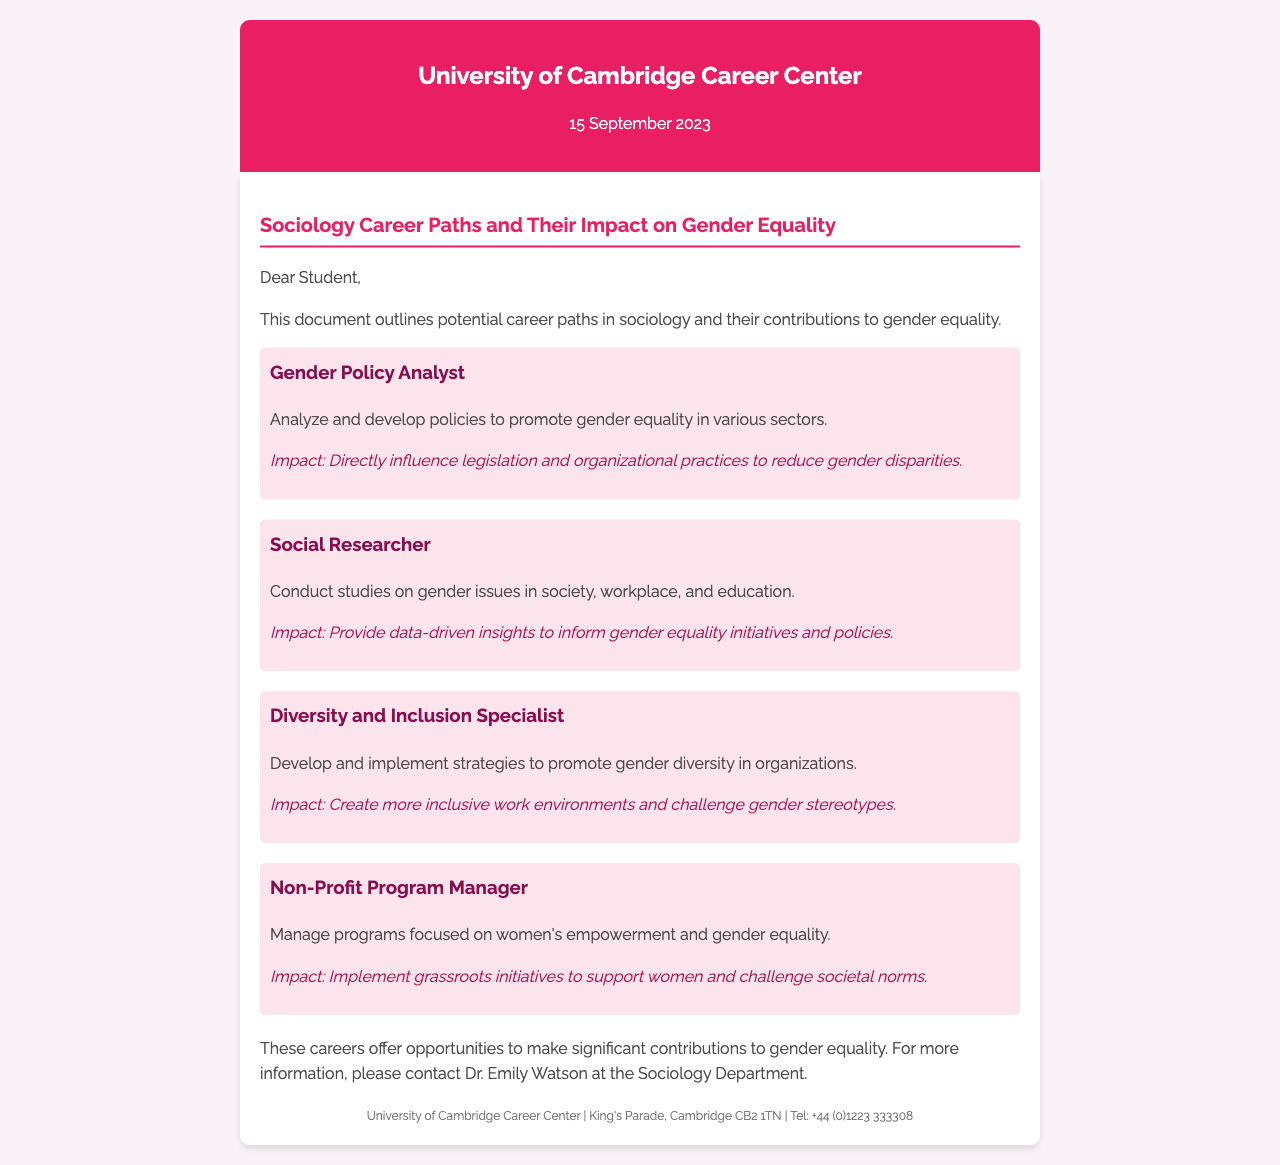What is the date of the document? The date of the document is mentioned prominently in the header.
Answer: 15 September 2023 Who sent the fax? The sender's information is included in the header of the document.
Answer: University of Cambridge Career Center What is the first career path mentioned? The career paths are clearly listed in the content of the document.
Answer: Gender Policy Analyst What is the impact of a Social Researcher? The impact is detailed under the career path descriptions.
Answer: Provide data-driven insights to inform gender equality initiatives and policies What role does a Diversity and Inclusion Specialist play? The document outlines the responsibilities of each career path.
Answer: Develop and implement strategies to promote gender diversity in organizations How many career paths are outlined in the document? The number of career paths can be counted from the sections described in the content.
Answer: Four Who should be contacted for more information? The contact information is provided at the end of the document.
Answer: Dr. Emily Watson What color is the fax header? The color of the header is described throughout the document's styling.
Answer: #e91e63 What is the primary focus of the careers listed? The overarching theme of the document is stated in the introduction.
Answer: Gender equality 